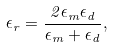Convert formula to latex. <formula><loc_0><loc_0><loc_500><loc_500>\epsilon _ { r } = \frac { 2 \epsilon _ { m } \epsilon _ { d } } { \epsilon _ { m } + \epsilon _ { d } } ,</formula> 